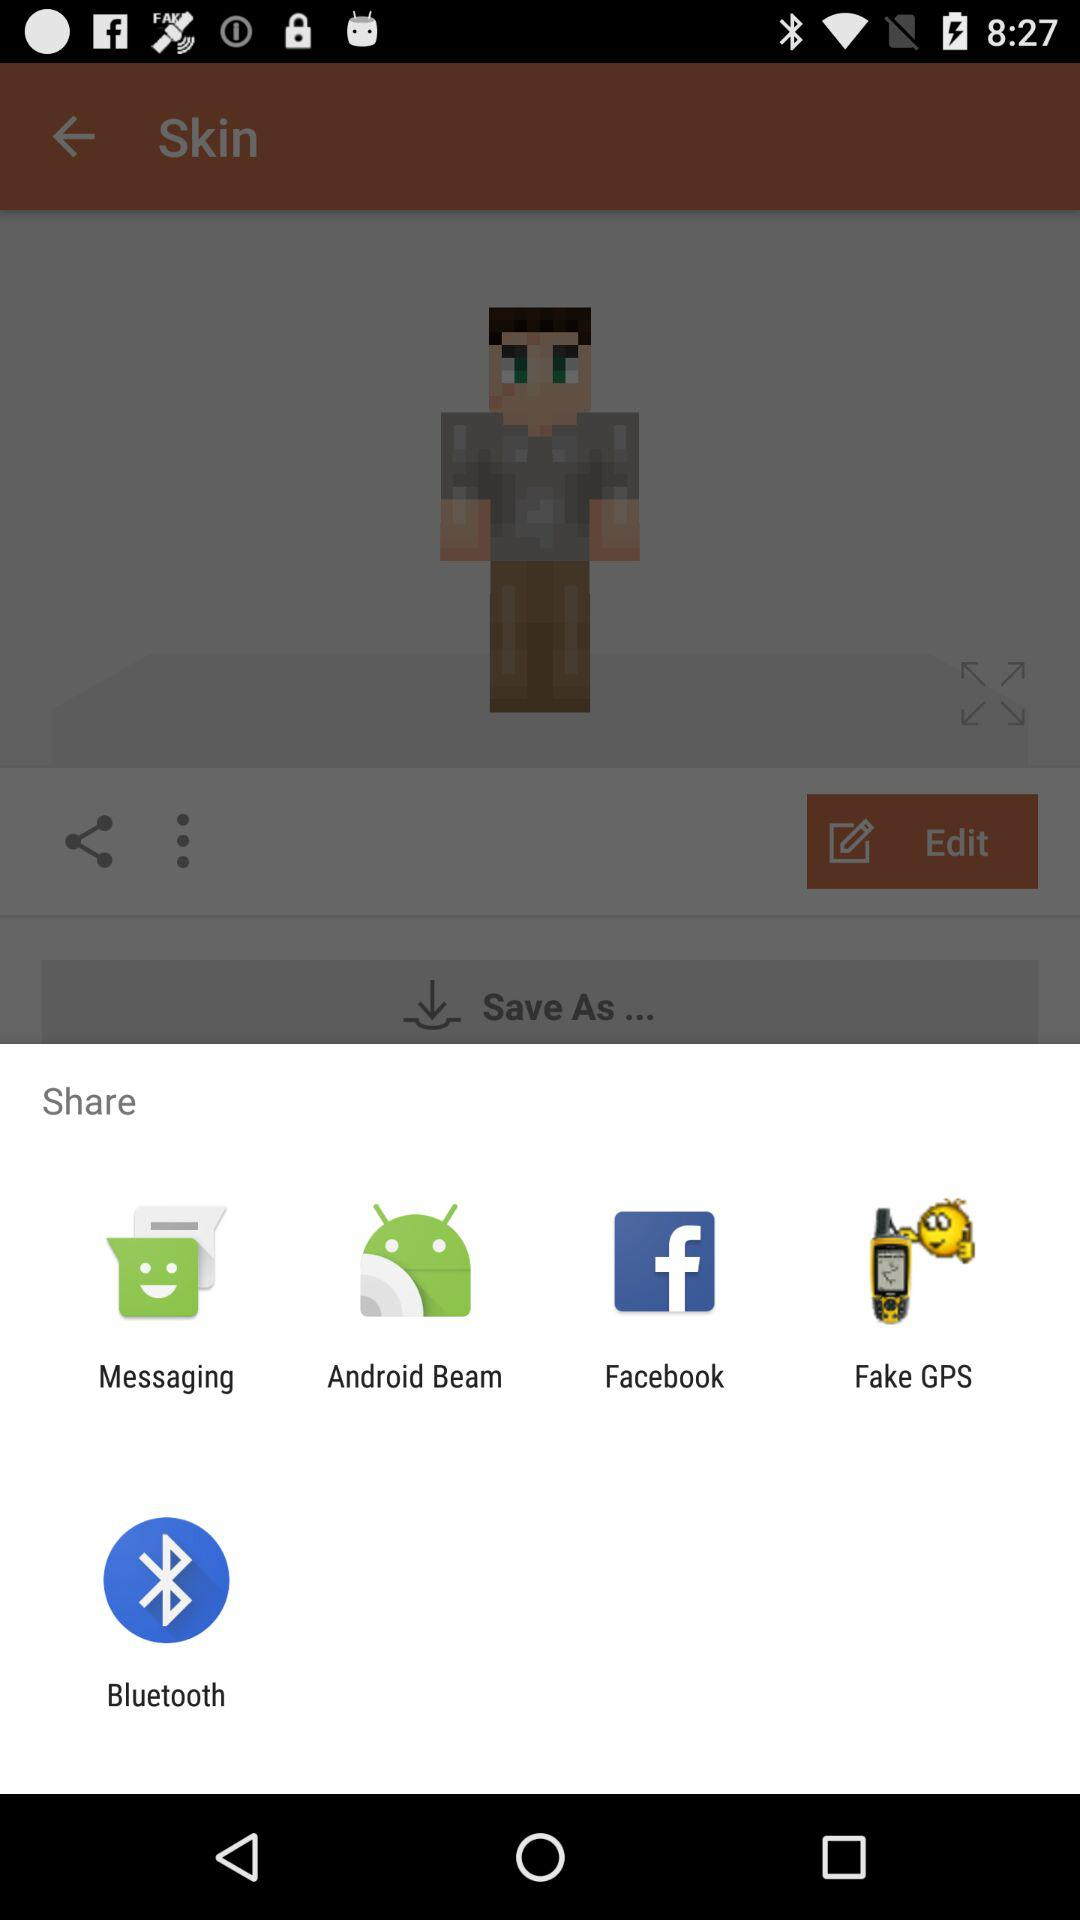What are the different options available for sharing? The different options available for sharing are "Messaging", "Android Beam", "Facebook", "Fake GPS" and "Bluetooth". 